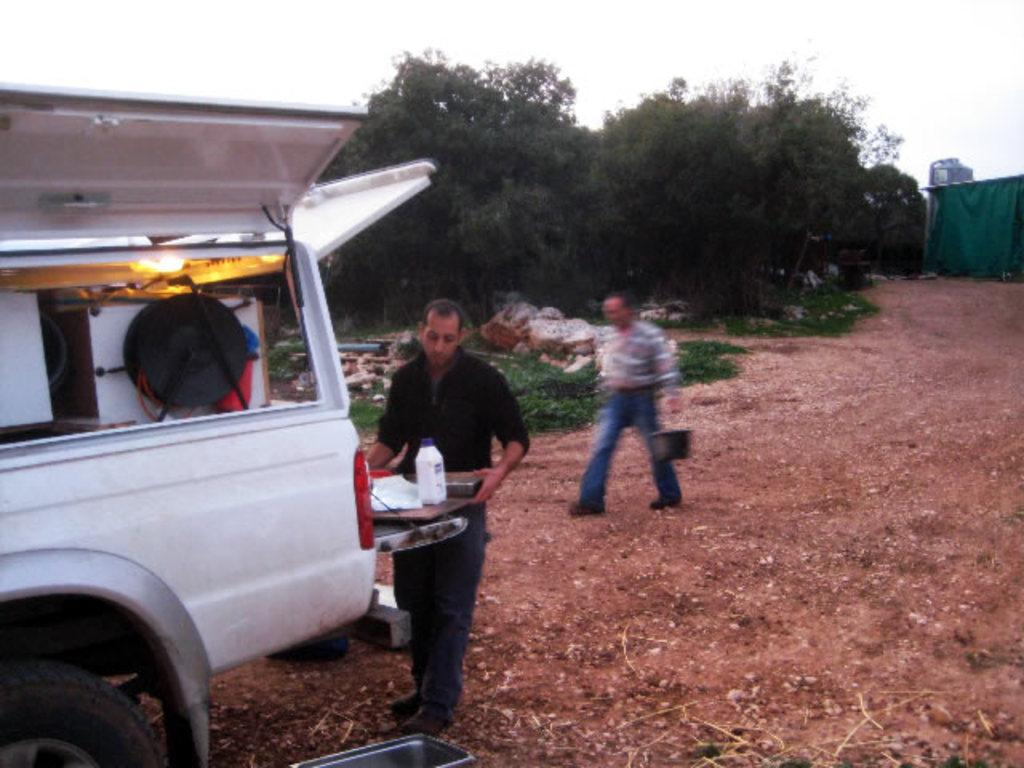How many people are present in the image? There are two persons in the image. What is located on the left side of the image? There is a vehicle on the left side of the image. What can be seen in the background of the image? There are trees and the sky visible in the background of the image. How many boys are riding the bike in the image? There is no bike present in the image, so it is not possible to answer that question. 